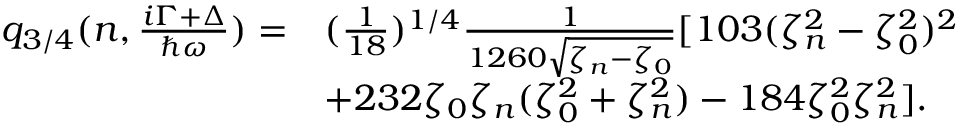<formula> <loc_0><loc_0><loc_500><loc_500>\begin{array} { r l } { q _ { 3 / 4 } ( n , \frac { i \Gamma + \Delta } { \hbar { \omega } } ) = } & { ( \frac { 1 } { 1 8 } ) ^ { 1 / 4 } \frac { 1 } { 1 2 6 0 \sqrt { \zeta _ { n } - \zeta _ { 0 } } } [ 1 0 3 ( \zeta _ { n } ^ { 2 } - \zeta _ { 0 } ^ { 2 } ) ^ { 2 } } \\ & { + 2 3 2 \zeta _ { 0 } \zeta _ { n } ( \zeta _ { 0 } ^ { 2 } + \zeta _ { n } ^ { 2 } ) - 1 8 4 \zeta _ { 0 } ^ { 2 } \zeta _ { n } ^ { 2 } ] . } \end{array}</formula> 